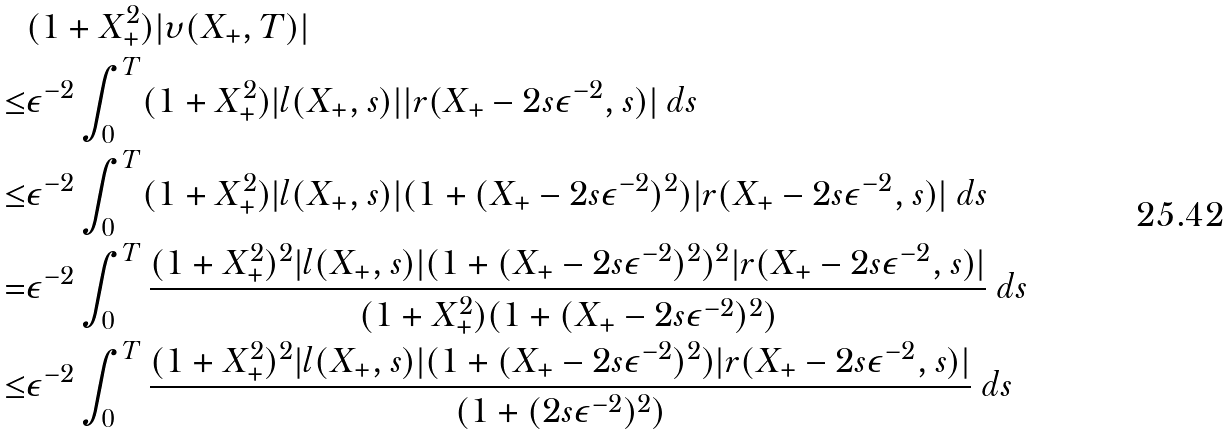Convert formula to latex. <formula><loc_0><loc_0><loc_500><loc_500>& ( 1 + X _ { + } ^ { 2 } ) | \upsilon ( X _ { + } , T ) | \\ \leq & \epsilon ^ { - 2 } \int _ { 0 } ^ { T } ( 1 + X _ { + } ^ { 2 } ) | l ( X _ { + } , s ) | | r ( X _ { + } - 2 s \epsilon ^ { - 2 } , s ) | \ d s \\ \leq & \epsilon ^ { - 2 } \int _ { 0 } ^ { T } ( 1 + X _ { + } ^ { 2 } ) | l ( X _ { + } , s ) | ( 1 + ( X _ { + } - 2 s \epsilon ^ { - 2 } ) ^ { 2 } ) | r ( X _ { + } - 2 s \epsilon ^ { - 2 } , s ) | \ d s \\ = & \epsilon ^ { - 2 } \int _ { 0 } ^ { T } \frac { ( 1 + X _ { + } ^ { 2 } ) ^ { 2 } | l ( X _ { + } , s ) | ( 1 + ( X _ { + } - 2 s \epsilon ^ { - 2 } ) ^ { 2 } ) ^ { 2 } | r ( X _ { + } - 2 s \epsilon ^ { - 2 } , s ) | } { ( 1 + X _ { + } ^ { 2 } ) ( 1 + ( X _ { + } - 2 s \epsilon ^ { - 2 } ) ^ { 2 } ) } \ d s \\ \leq & \epsilon ^ { - 2 } \int _ { 0 } ^ { T } \frac { ( 1 + X _ { + } ^ { 2 } ) ^ { 2 } | l ( X _ { + } , s ) | ( 1 + ( X _ { + } - 2 s \epsilon ^ { - 2 } ) ^ { 2 } ) | r ( X _ { + } - 2 s \epsilon ^ { - 2 } , s ) | } { ( 1 + ( 2 s \epsilon ^ { - 2 } ) ^ { 2 } ) } \ d s</formula> 